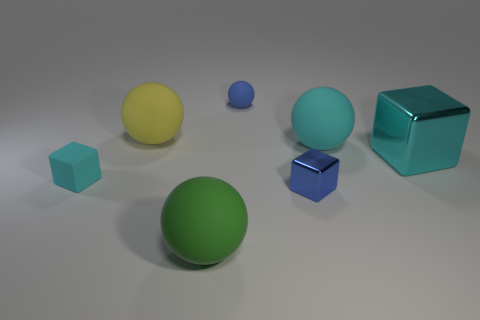There is a thing that is right of the big green matte object and in front of the cyan matte block; what is its shape?
Provide a succinct answer. Cube. How many big cylinders are made of the same material as the yellow object?
Your response must be concise. 0. How many green matte things are there?
Make the answer very short. 1. There is a green thing; does it have the same size as the cyan cube to the right of the big yellow sphere?
Offer a terse response. Yes. What is the material of the tiny cube right of the matte ball in front of the big cyan block?
Provide a short and direct response. Metal. There is a metallic thing that is to the right of the cyan rubber thing that is behind the block behind the tiny cyan cube; how big is it?
Provide a succinct answer. Large. There is a large cyan metal thing; is its shape the same as the small matte thing that is in front of the blue ball?
Your answer should be compact. Yes. What is the big cyan block made of?
Provide a short and direct response. Metal. How many rubber objects are large things or cyan spheres?
Your response must be concise. 3. Are there fewer large spheres to the left of the cyan ball than small rubber spheres that are in front of the blue shiny thing?
Give a very brief answer. No. 